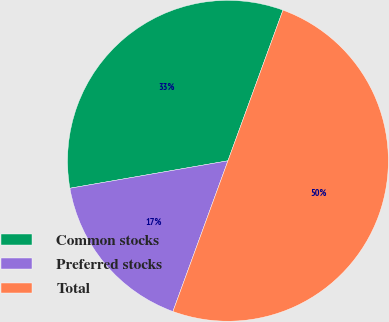Convert chart to OTSL. <chart><loc_0><loc_0><loc_500><loc_500><pie_chart><fcel>Common stocks<fcel>Preferred stocks<fcel>Total<nl><fcel>33.31%<fcel>16.69%<fcel>50.0%<nl></chart> 